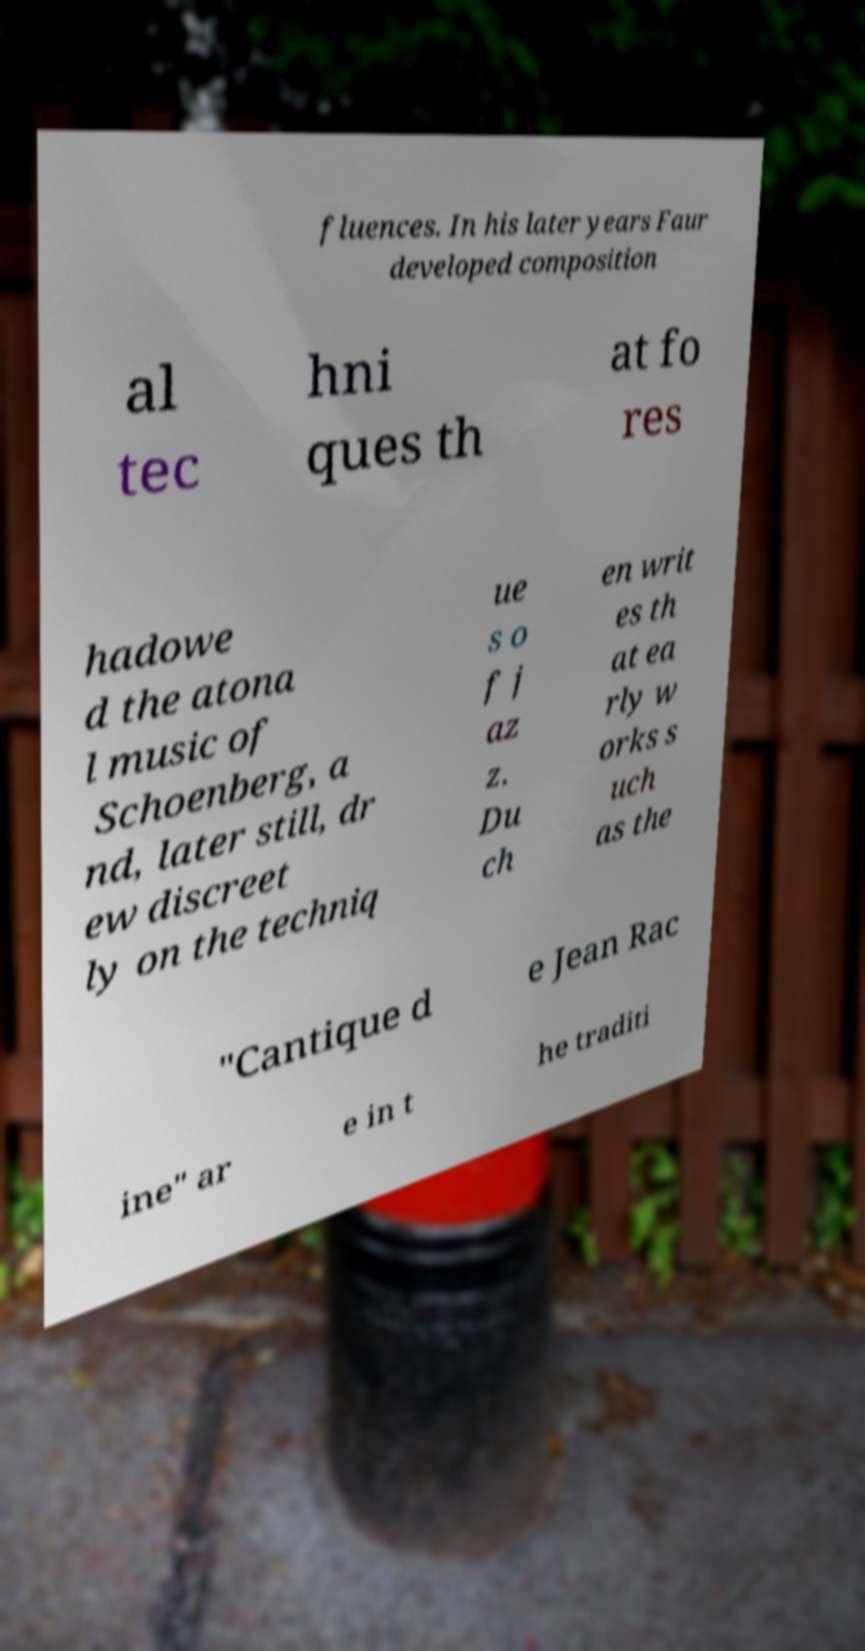Please identify and transcribe the text found in this image. fluences. In his later years Faur developed composition al tec hni ques th at fo res hadowe d the atona l music of Schoenberg, a nd, later still, dr ew discreet ly on the techniq ue s o f j az z. Du ch en writ es th at ea rly w orks s uch as the "Cantique d e Jean Rac ine" ar e in t he traditi 